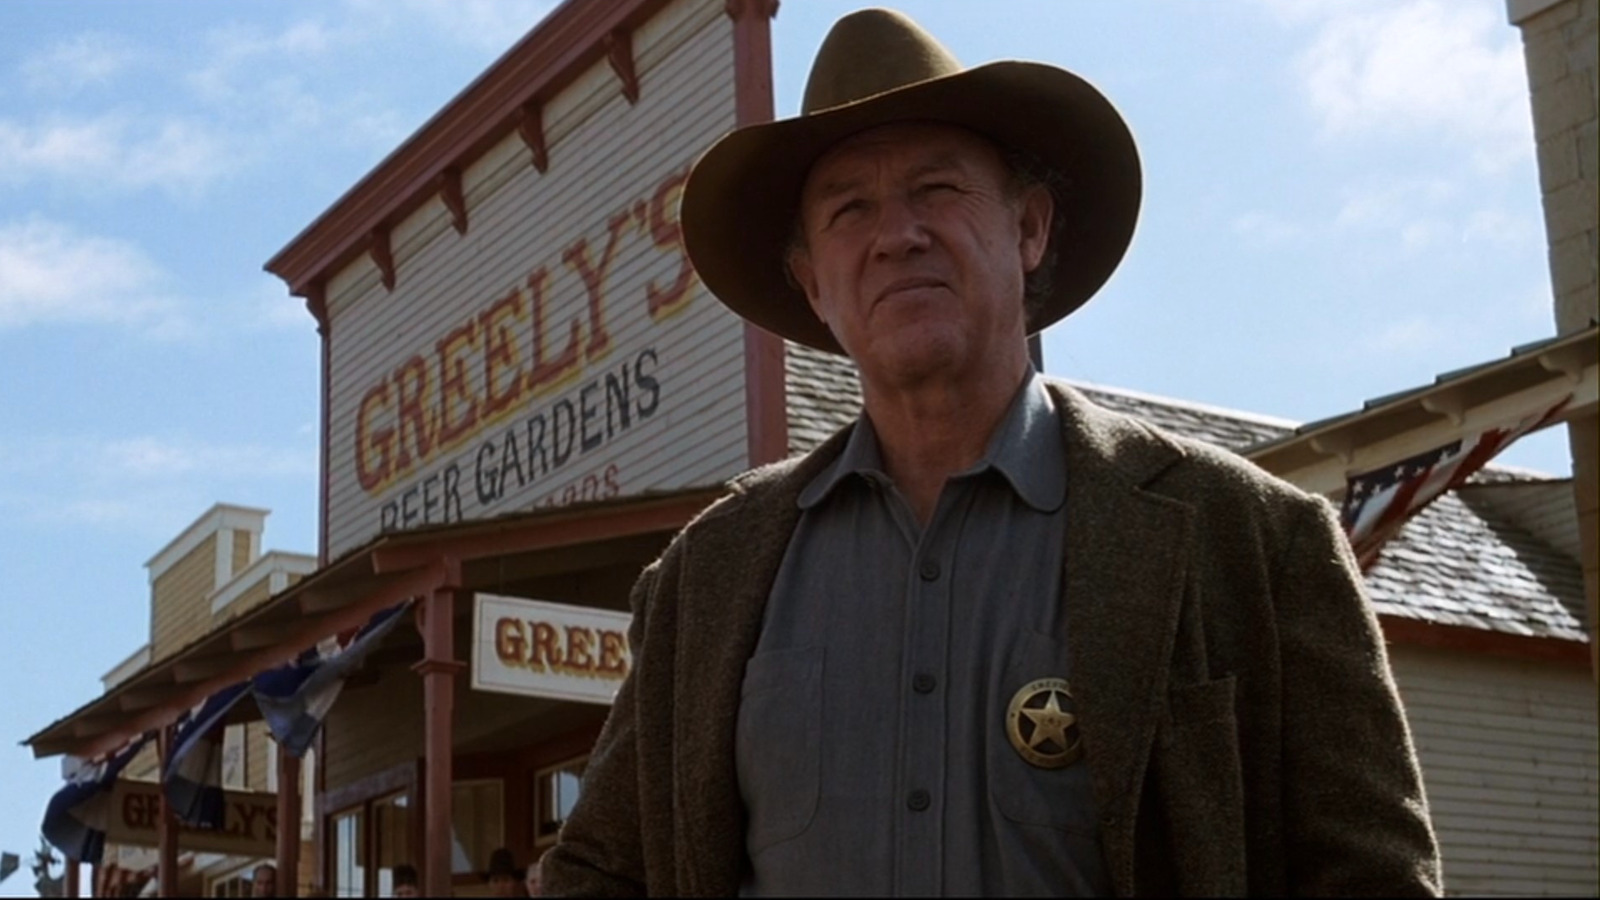Imagine if this setting had a modern twist. What kind of scenario could be depicted? Imagine the scene with a modern twist: The man in the image, still holding the position of a sheriff, is now dressed in contemporary law enforcement attire, including sunglasses and a tactical vest. 'Greeley's Beer Gardens' has been transformed into a lively brewpub, with neon signs and modern decor. Instead of the dusty streets of the old west, we see parked vehicles and bustling town life in the background. Passersby watch as Sheriff Greeley stands guard, maintaining order in this modern, yet historically rich town. 